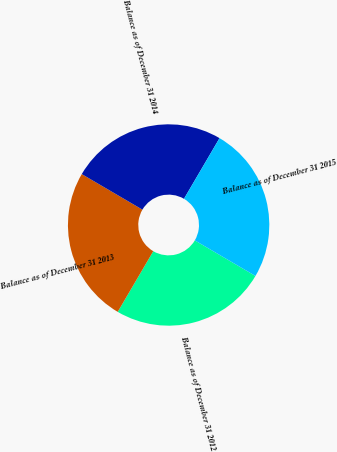Convert chart to OTSL. <chart><loc_0><loc_0><loc_500><loc_500><pie_chart><fcel>Balance as of December 31 2012<fcel>Balance as of December 31 2013<fcel>Balance as of December 31 2014<fcel>Balance as of December 31 2015<nl><fcel>24.99%<fcel>25.0%<fcel>25.0%<fcel>25.01%<nl></chart> 